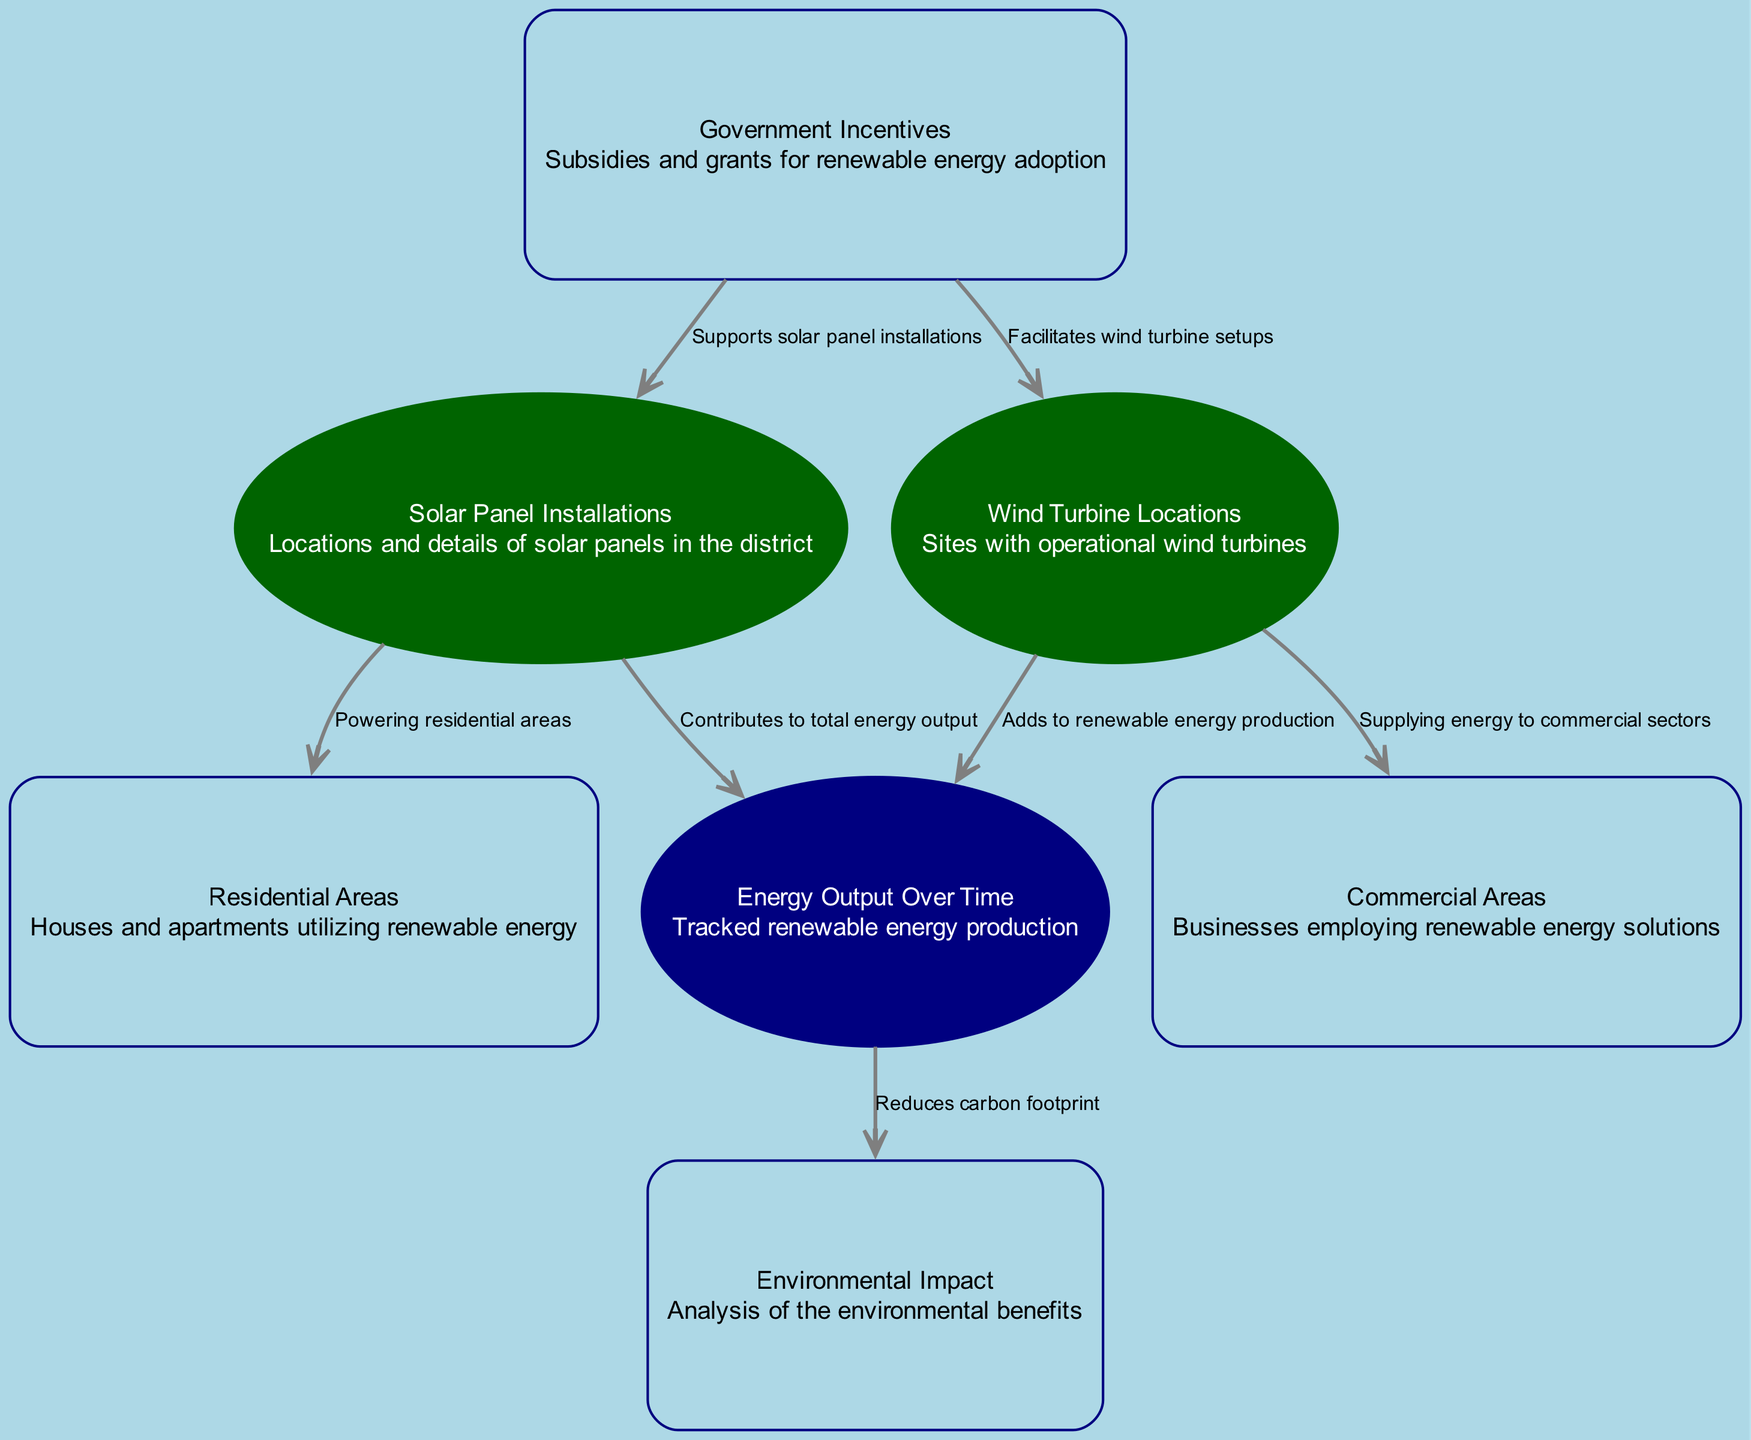What are the two main types of renewable energy installations in the district? The diagram features two main types of renewable energy installations: solar panel installations and wind turbine locations. These are highlighted as nodes 1 and 2.
Answer: Solar panel installations and wind turbine locations How many nodes are present in the diagram? The diagram contains a total of seven nodes representing various aspects of renewable energy adoption, as listed in the data.
Answer: Seven What is the relationship between solar panel installations and energy output? The diagram shows a directed edge from "Solar Panel Installations" to "Energy Output Over Time," indicating that solar panel installations contribute to total energy output.
Answer: Contributes to total energy output Which type of area is powered by wind turbines? According to the edge in the diagram, wind turbines supply energy specifically to commercial sectors, indicating their primary area of impact.
Answer: Commercial areas What does government incentives support in this diagram? The edges illustrate that government incentives facilitate both solar panel installations and wind turbine setups, meaning they provide support for both types of renewable energy installation.
Answer: Solar panel installations and wind turbine setups How does energy output impact environmental benefits? The diagram indicates that energy output over time reduces the carbon footprint, establishing a direct link between energy output and environmental benefits.
Answer: Reduces carbon footprint What is described by the node "Environmental Impact"? The node "Environmental Impact" is defined in the diagram as an analysis of the environmental benefits from renewable energy adoption shown in the diagram.
Answer: Analysis of the environmental benefits 